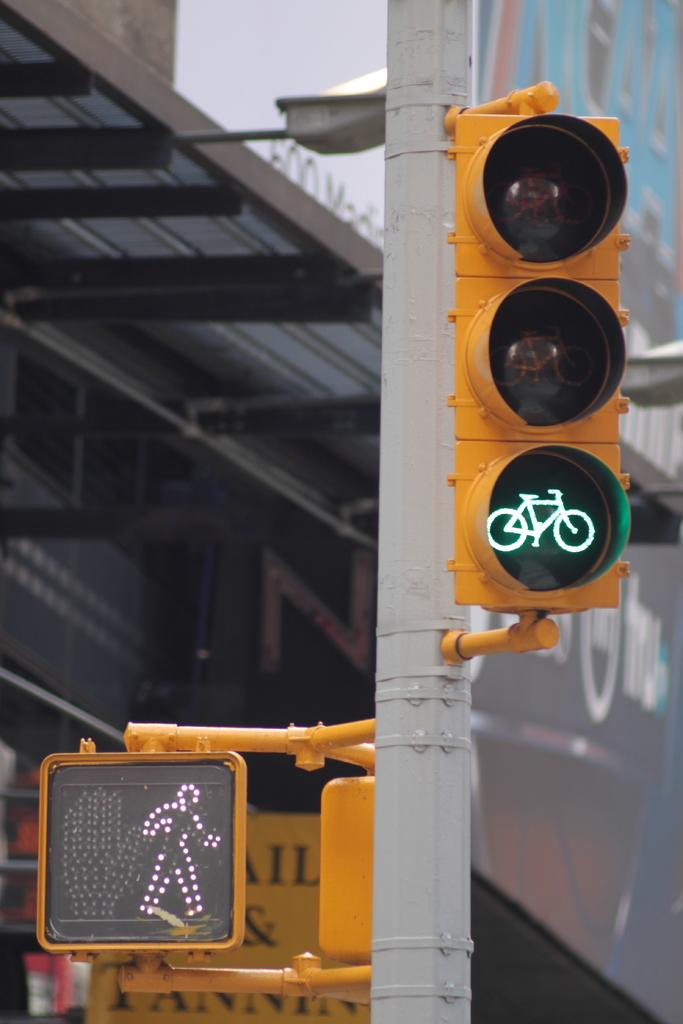Provide a one-sentence caption for the provided image. The letters IL and visible behind a walk/don't walk sign. 